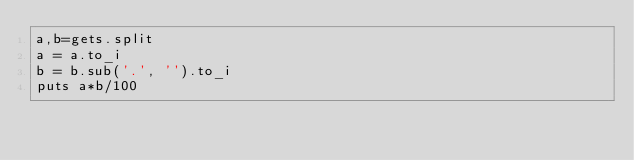Convert code to text. <code><loc_0><loc_0><loc_500><loc_500><_Ruby_>a,b=gets.split
a = a.to_i
b = b.sub('.', '').to_i
puts a*b/100
</code> 